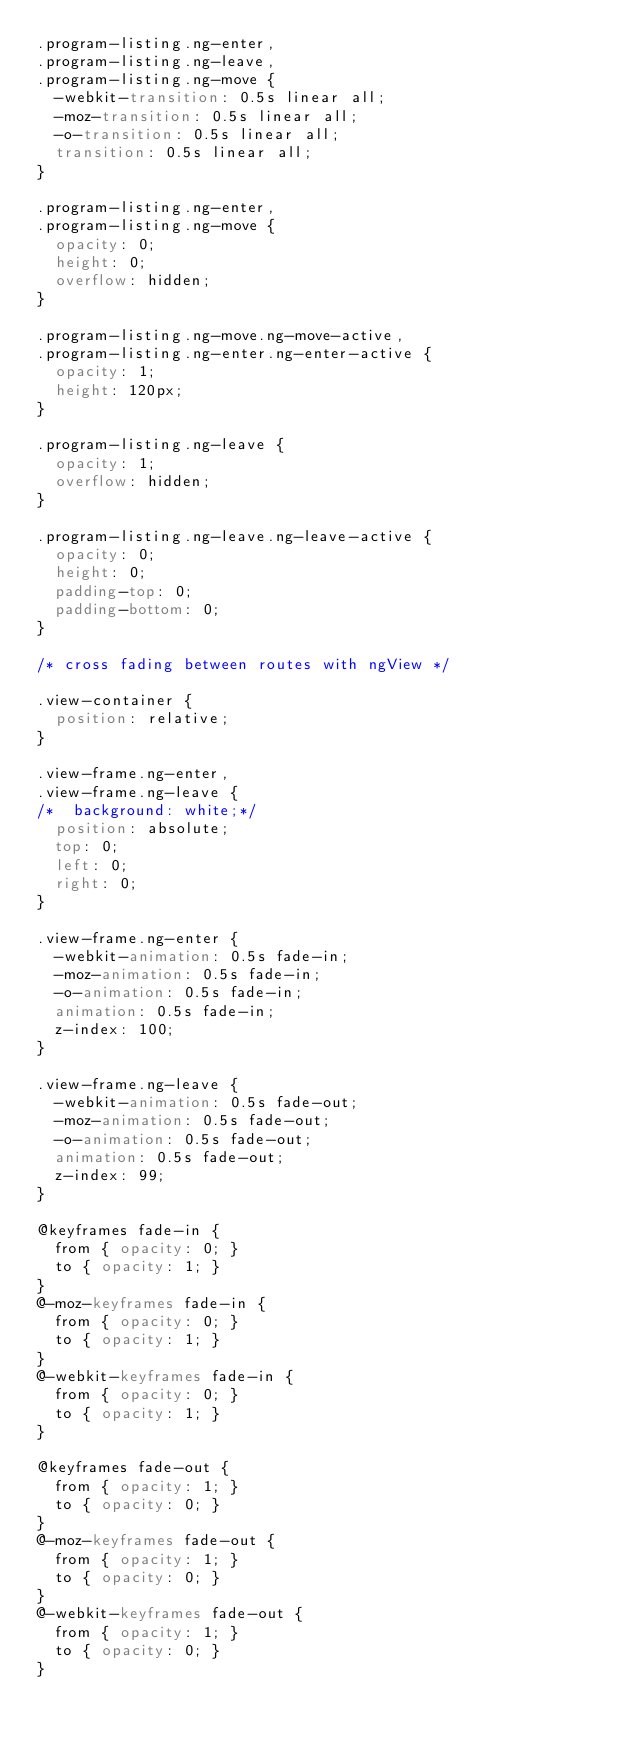Convert code to text. <code><loc_0><loc_0><loc_500><loc_500><_CSS_>.program-listing.ng-enter,
.program-listing.ng-leave,
.program-listing.ng-move {
  -webkit-transition: 0.5s linear all;
  -moz-transition: 0.5s linear all;
  -o-transition: 0.5s linear all;
  transition: 0.5s linear all;
}

.program-listing.ng-enter,
.program-listing.ng-move {
  opacity: 0;
  height: 0;
  overflow: hidden;
}

.program-listing.ng-move.ng-move-active,
.program-listing.ng-enter.ng-enter-active {
  opacity: 1;
  height: 120px;
}

.program-listing.ng-leave {
  opacity: 1;
  overflow: hidden;
}

.program-listing.ng-leave.ng-leave-active {
  opacity: 0;
  height: 0;
  padding-top: 0;
  padding-bottom: 0;
}

/* cross fading between routes with ngView */

.view-container {
  position: relative;
}

.view-frame.ng-enter,
.view-frame.ng-leave {
/*  background: white;*/
  position: absolute;
  top: 0;
  left: 0;
  right: 0;
}

.view-frame.ng-enter {
  -webkit-animation: 0.5s fade-in;
  -moz-animation: 0.5s fade-in;
  -o-animation: 0.5s fade-in;
  animation: 0.5s fade-in;
  z-index: 100;
}

.view-frame.ng-leave {
  -webkit-animation: 0.5s fade-out;
  -moz-animation: 0.5s fade-out;
  -o-animation: 0.5s fade-out;
  animation: 0.5s fade-out;
  z-index: 99;
}

@keyframes fade-in {
  from { opacity: 0; }
  to { opacity: 1; }
}
@-moz-keyframes fade-in {
  from { opacity: 0; }
  to { opacity: 1; }
}
@-webkit-keyframes fade-in {
  from { opacity: 0; }
  to { opacity: 1; }
}

@keyframes fade-out {
  from { opacity: 1; }
  to { opacity: 0; }
}
@-moz-keyframes fade-out {
  from { opacity: 1; }
  to { opacity: 0; }
}
@-webkit-keyframes fade-out {
  from { opacity: 1; }
  to { opacity: 0; }
}
</code> 